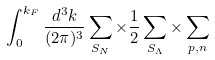Convert formula to latex. <formula><loc_0><loc_0><loc_500><loc_500>\int ^ { k _ { F } } _ { 0 } \frac { d ^ { 3 } k } { ( 2 \pi ) ^ { 3 } } \sum _ { S _ { N } } \times \frac { 1 } { 2 } \sum _ { S _ { \Lambda } } \times \sum _ { p , n }</formula> 